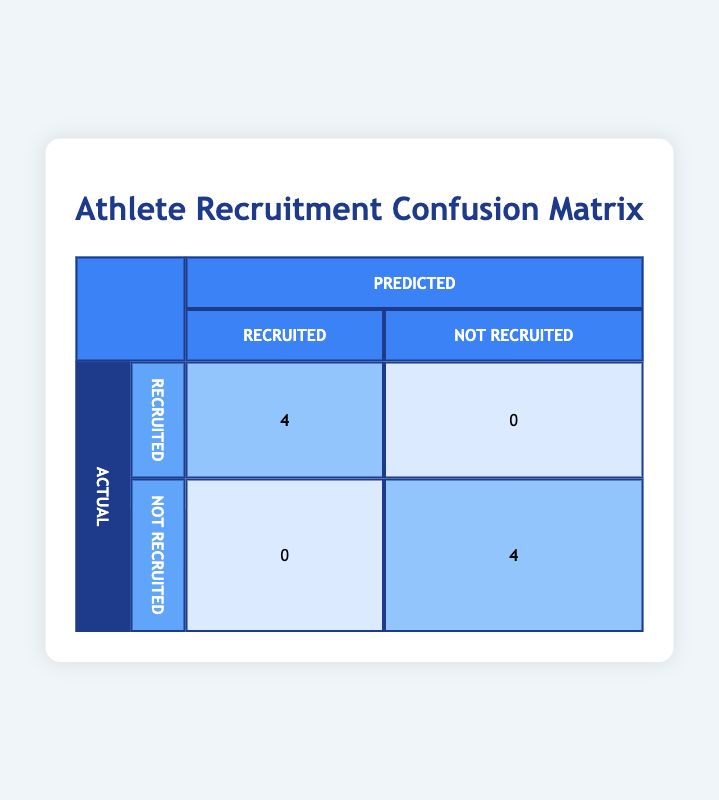What is the total number of athletes who were recruited? The table shows that there are 4 athletes classified as "Recruited." These can be seen in the "Recruited" row under the "Actual" classification, where the value is highlighted as 4.
Answer: 4 How many athletes were not recruited? Similarly, in the table, there are 4 athletes classified as "Not Recruited," which can be found in the "Not Recruited" row under the "Actual" classification, where the value is highlighted as 4.
Answer: 4 Is it true that all athletes with high academic performance were recruited? Yes, checking the "Recruited" row, all 4 athletes in that category have either high athletic achievement and high academic performance, confirming that all with high academic performance were indeed recruited.
Answer: Yes What is the number of athletes classified as "Not Recruited" who also have low athletic achievement? Looking at the table, the "Not Recruited" category shows that there are 4 athletes in total. Among these, only one athlete, Alyssa Patel, has low athletic achievement, confirming the count for that specific condition.
Answer: 1 What is the ratio of recruited to not recruited athletes? The number of recruited athletes is 4 and the number of not recruited athletes is also 4. Thus, the ratio can be computed as 4:4, which simplifies to 1:1.
Answer: 1:1 Which classification has more athletes, recruited or not recruited? The table shows there are 4 athletes in each classification (recruited and not recruited). Therefore, neither classification has more athletes; they are equal.
Answer: Neither If we combine the academic performance levels of the recruited athletes, what is the distribution of their classifications? In the table, the recruited athletes consist of 3 high academic performance and 1 medium. So, the distribution is three athletes with high performance and one athlete with medium performance.
Answer: 3 High, 1 Medium Are there any athletes with low athletic achievement who were recruited? Looking under the "Recruited" column, it’s evident that all recruited athletes possess either high or medium athletic achievements. None of them have low achievement, confirming that no recruited athlete falls into the low category.
Answer: No What percentage of all athletes are classified as recruited? There are 8 athletes total, and 4 are classified as recruited. To find the percentage, divide the number of recruited athletes (4) by the total athlete count (8), which gives 4/8 = 0.5. Multiplied by 100 for the percentage yields 50%.
Answer: 50% 